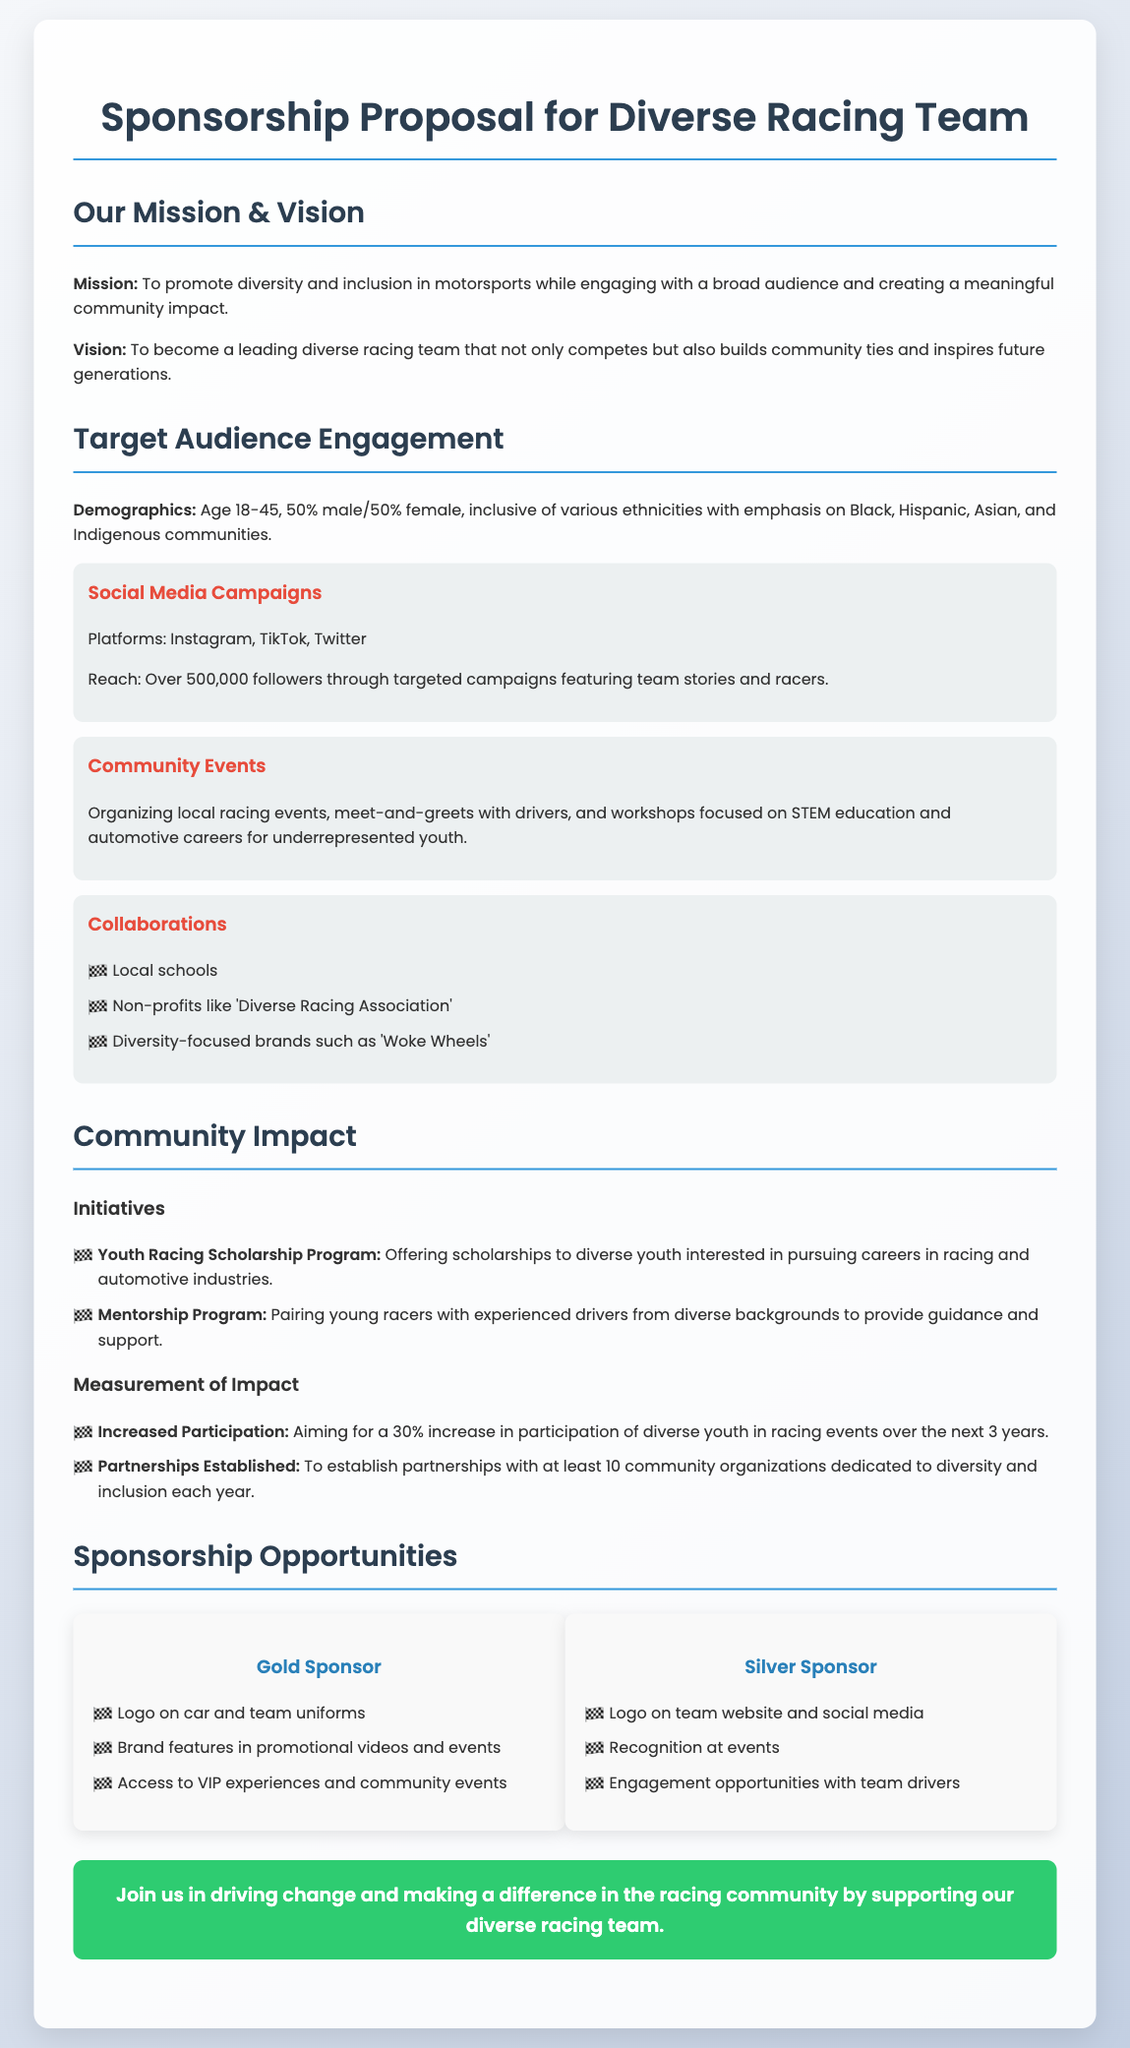What is the mission of the racing team? The mission is to promote diversity and inclusion in motorsports while engaging with a broad audience and creating a meaningful community impact.
Answer: To promote diversity and inclusion in motorsports What is the age range of the target audience? The document specifies the target audience's age range from 18 to 45.
Answer: 18-45 What community organization is named in the collaborations? One of the collaborations mentioned is with 'Diverse Racing Association'.
Answer: Diverse Racing Association What is the goal for increased participation of diverse youth in racing events? The goal stated is a 30% increase in participation over the next 3 years.
Answer: 30% What are the benefits for Gold Sponsors? Gold Sponsors receive several benefits, including logo placement on car and uniforms as well as access to VIP experiences.
Answer: Logo on car and team uniforms How many community organizations does the document aim to partner with each year? The document states an aim to establish partnerships with at least 10 community organizations each year.
Answer: 10 What is one initiative aimed at youth mentioned in the document? The initiative mentioned is the Youth Racing Scholarship Program.
Answer: Youth Racing Scholarship Program Which social media platforms are used for campaigns? The document lists Instagram, TikTok, and Twitter as the platforms used for social media campaigns.
Answer: Instagram, TikTok, Twitter What is the vision of the diverse racing team? The vision is to become a leading diverse racing team that builds community ties and inspires future generations.
Answer: To become a leading diverse racing team 